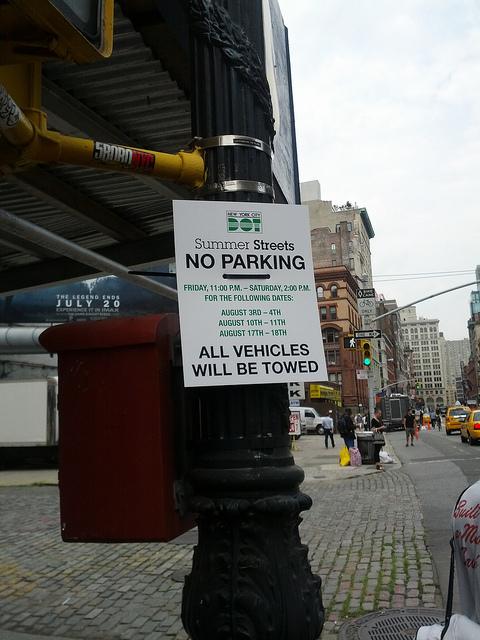What is this poster trying to accomplish?
Answer briefly. No parking. What is this black thing for?
Be succinct. Pole. Is this a city street?
Write a very short answer. Yes. Is this a place that you can park?
Write a very short answer. No. What image appears on the green sign?
Write a very short answer. Nothing. What does the sign say above no parking?
Quick response, please. Summer streets. 